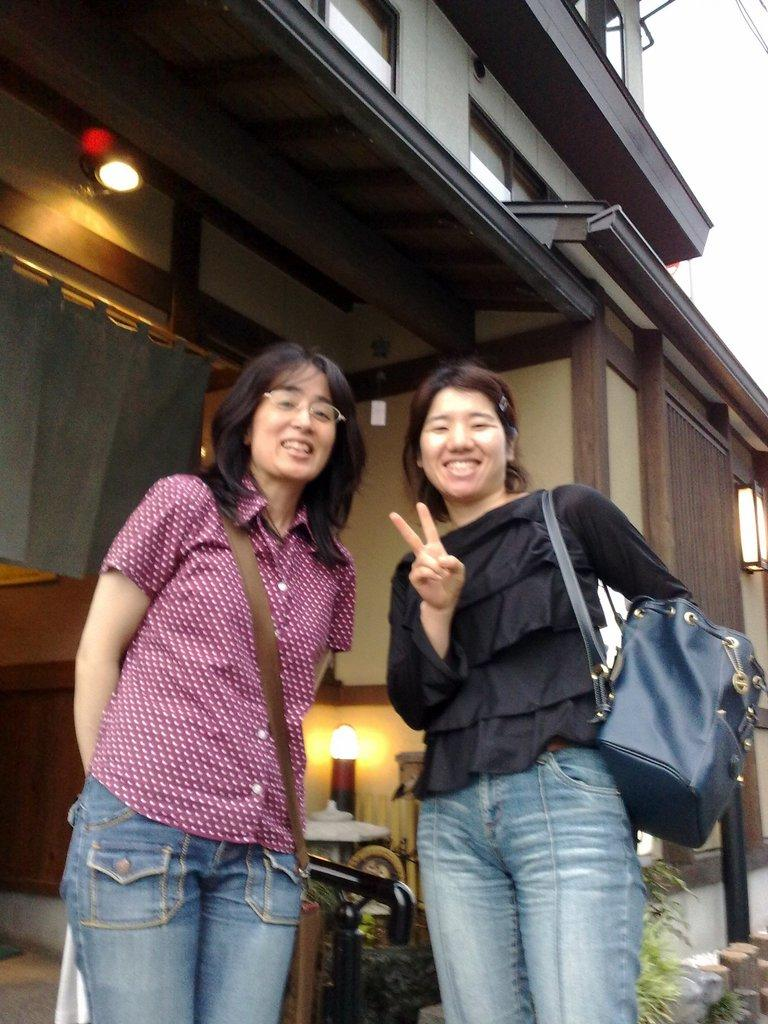How many women are in the image? There are 2 women in the image. What are the women doing in the image? Both women are standing and smiling. What are the women holding in the image? Both women are carrying bags. What can be seen in the background of the image? There is a building, plants, and 2 lights visible in the background of the image. What is the weight of the scale in the image? There is no scale present in the image. 